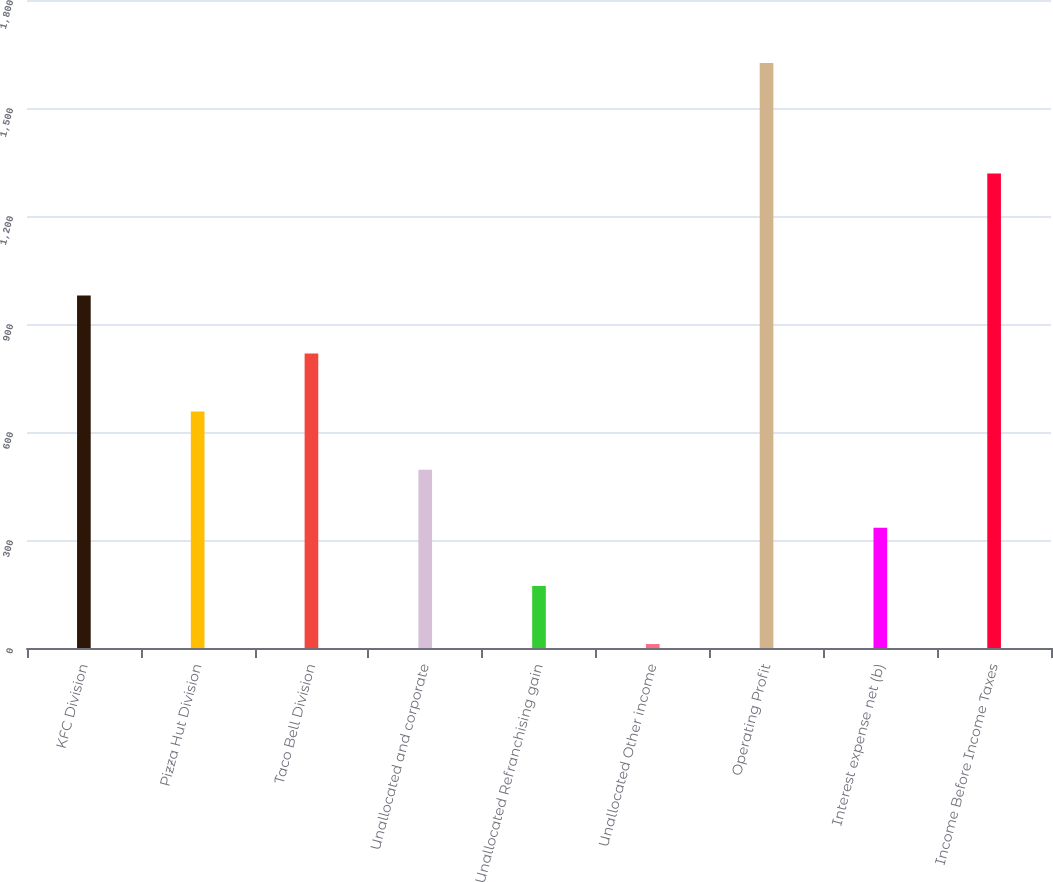<chart> <loc_0><loc_0><loc_500><loc_500><bar_chart><fcel>KFC Division<fcel>Pizza Hut Division<fcel>Taco Bell Division<fcel>Unallocated and corporate<fcel>Unallocated Refranchising gain<fcel>Unallocated Other income<fcel>Operating Profit<fcel>Interest expense net (b)<fcel>Income Before Income Taxes<nl><fcel>979.4<fcel>656.6<fcel>818<fcel>495.2<fcel>172.4<fcel>11<fcel>1625<fcel>333.8<fcel>1318<nl></chart> 